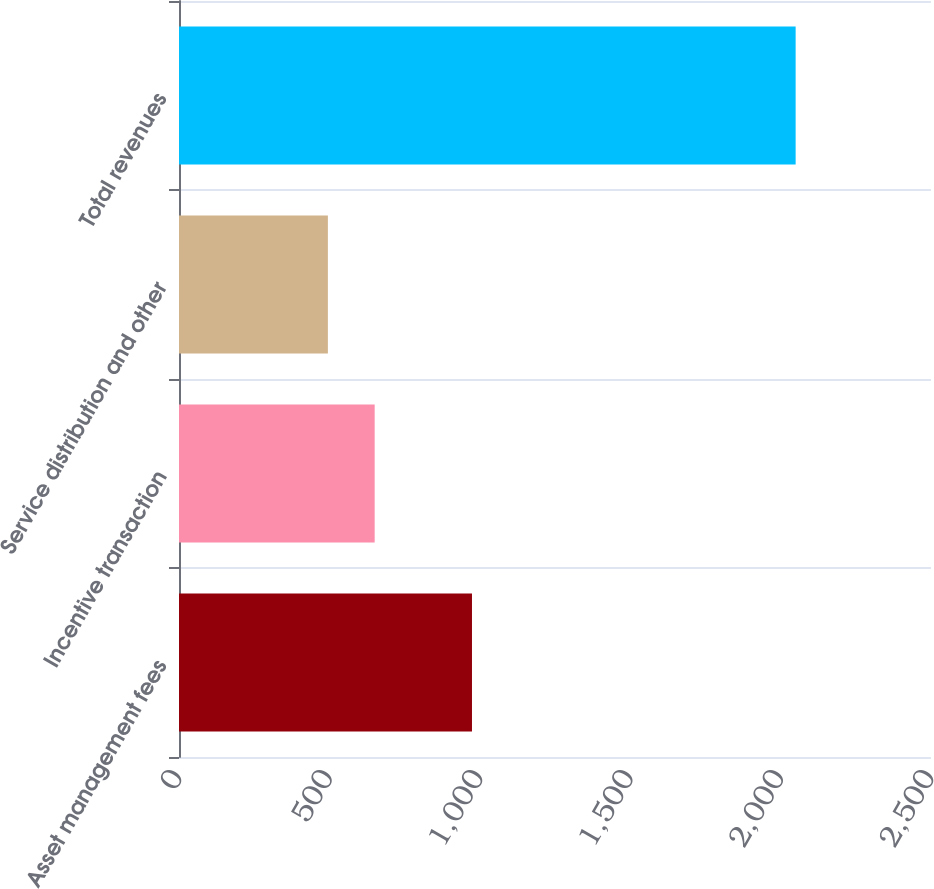Convert chart. <chart><loc_0><loc_0><loc_500><loc_500><bar_chart><fcel>Asset management fees<fcel>Incentive transaction<fcel>Service distribution and other<fcel>Total revenues<nl><fcel>974<fcel>650.5<fcel>495<fcel>2050<nl></chart> 